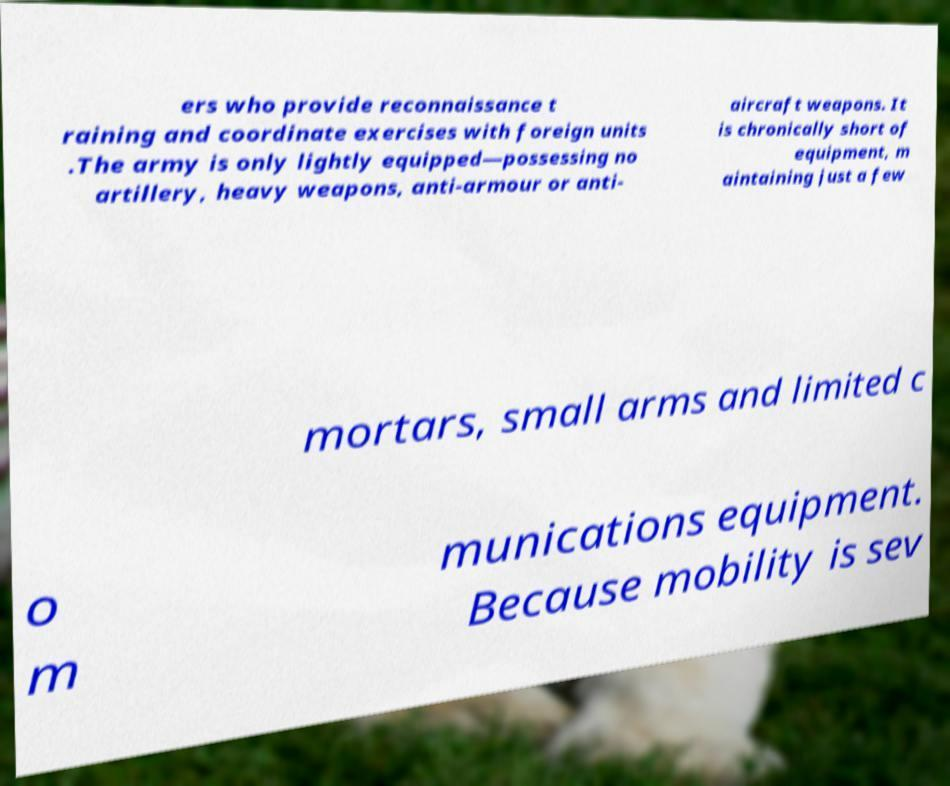Please read and relay the text visible in this image. What does it say? ers who provide reconnaissance t raining and coordinate exercises with foreign units .The army is only lightly equipped—possessing no artillery, heavy weapons, anti-armour or anti- aircraft weapons. It is chronically short of equipment, m aintaining just a few mortars, small arms and limited c o m munications equipment. Because mobility is sev 